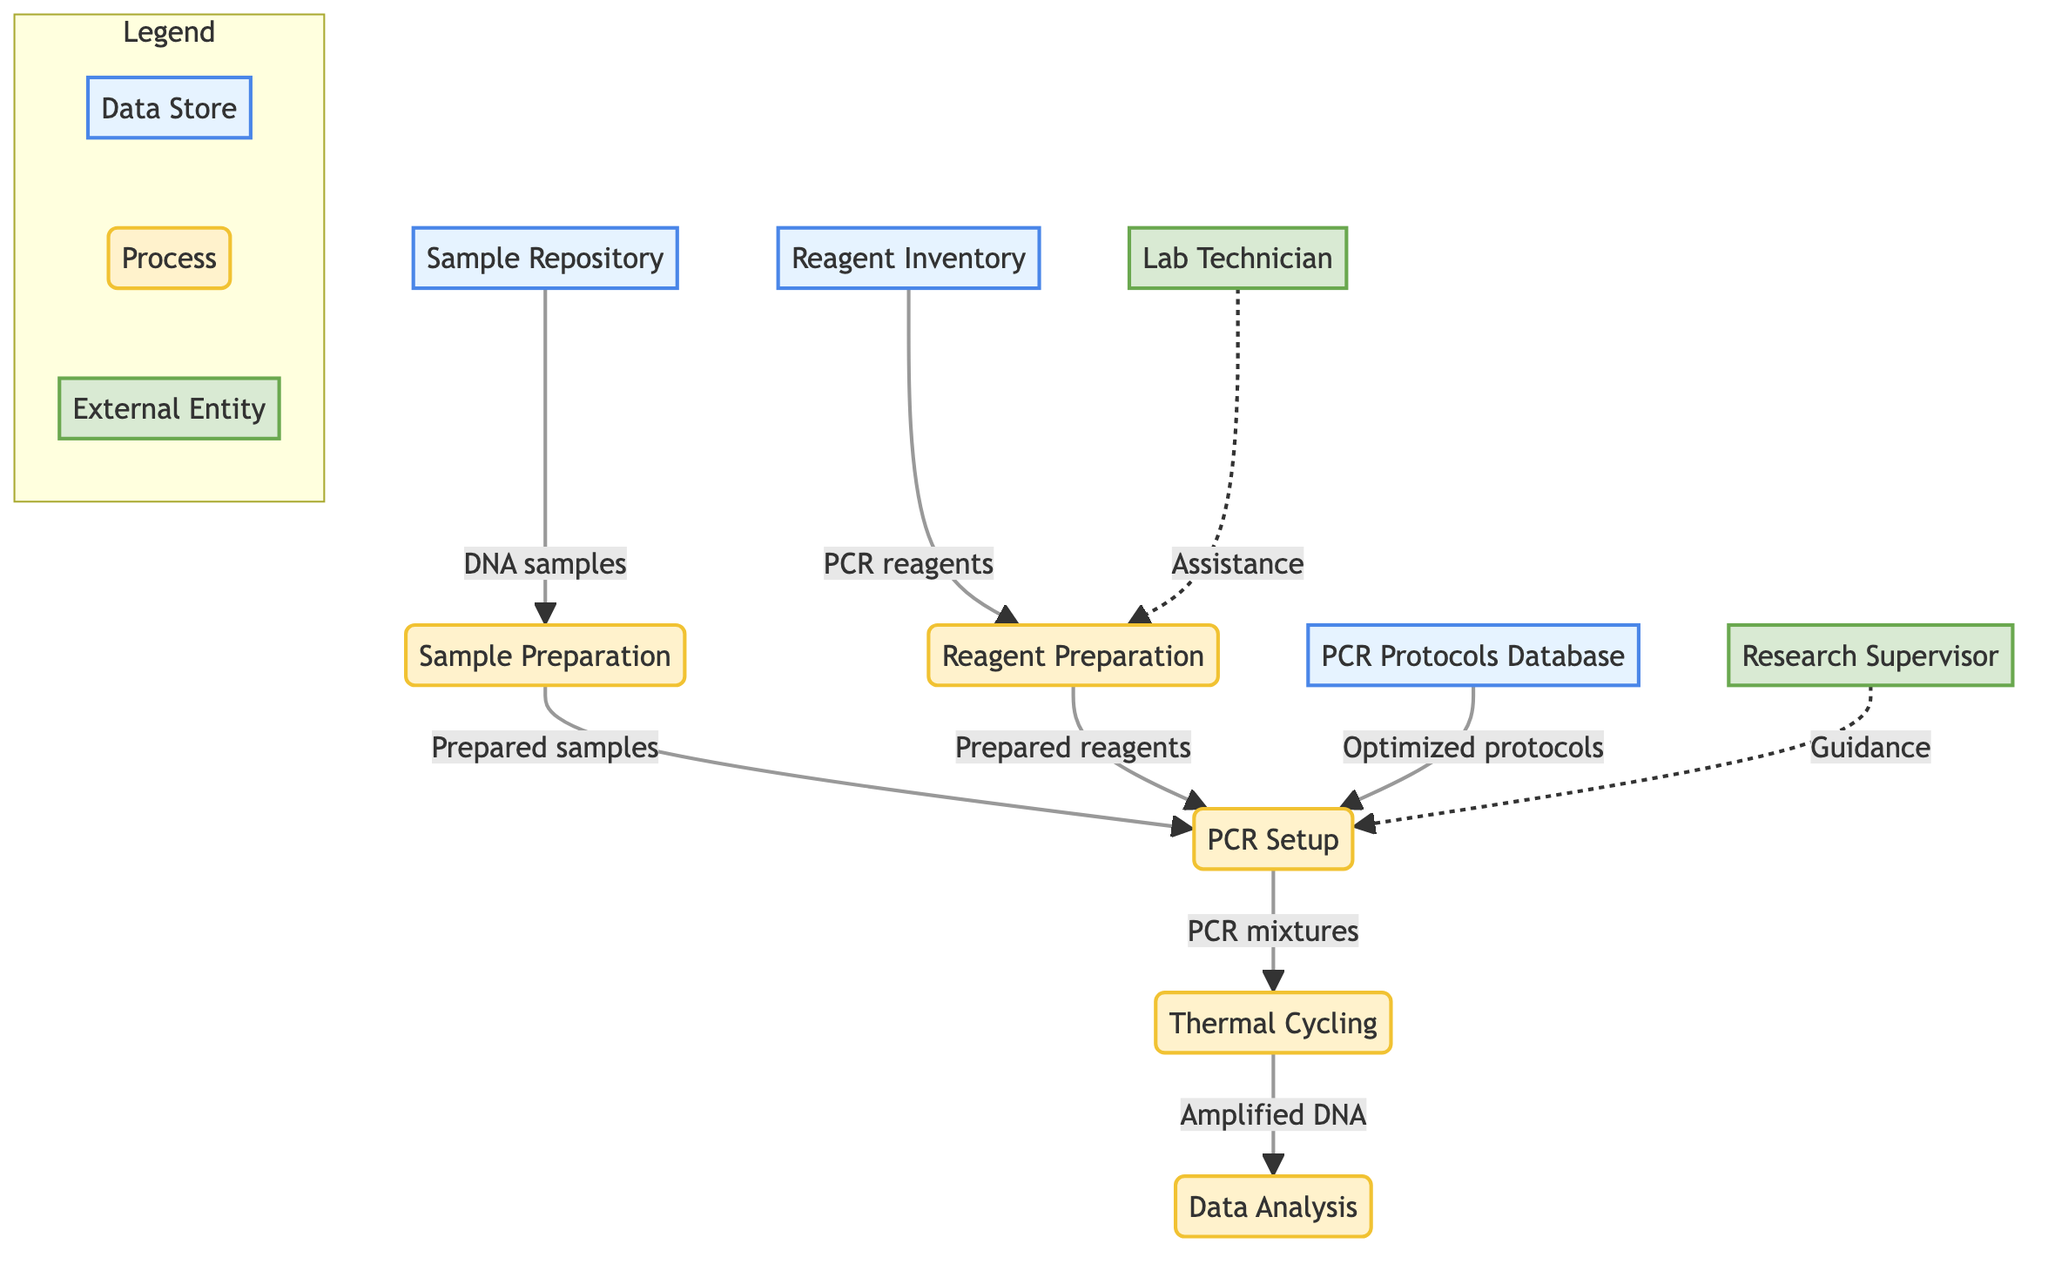What is the first process in the workflow? The first process in the workflow is labeled "Sample Preparation," which is indicated by the arrow coming from the "Sample Repository" data store flowing into it.
Answer: Sample Preparation How many data stores are present in this diagram? The diagram clearly lists three data stores: "Sample Repository," "Reagent Inventory," and "PCR Protocols Database," which can be counted directly in the diagram.
Answer: 3 Which external entity provides guidance for PCR experiment protocols? The external entity labeled "Research Supervisor" is depicted with a dotted line showing their guidance flow going into the "PCR Setup" process.
Answer: Research Supervisor What flows into the PCR Setup process? The PCR Setup process receives flows from three sources: "Prepared samples" from "Sample Preparation," "Prepared reagents" from "Reagent Preparation," and "Optimized protocols" from "PCR Protocols Database," visibly indicated by arrows pointing to it.
Answer: Prepared samples, Prepared reagents, Optimized protocols What comes after Thermal Cycling in the workflow? Following the "Thermal Cycling" process, the next step in the workflow is "Data Analysis," as indicated by the flow from "Thermal Cycling" to "Data Analysis" in the diagram.
Answer: Data Analysis How many processes are involved in the PCR workflow? The diagram outlines five processes: "Sample Preparation," "Reagent Preparation," "PCR Setup," "Thermal Cycling," and "Data Analysis," which can be verified by counting the labeled process nodes.
Answer: 5 What is the role of the Lab Technician in the workflow? The "Lab Technician" external entity is indicated to assist with the preparation of reagents, flowing into the "Reagent Preparation" process, which highlights their supportive role in the laboratorial processes.
Answer: Assistance Which process sends amplified DNA samples for analysis? The process responsible for sending amplified DNA samples for analysis is "Thermal Cycling," as shown by the arrow that directs to the "Data Analysis" process.
Answer: Thermal Cycling 